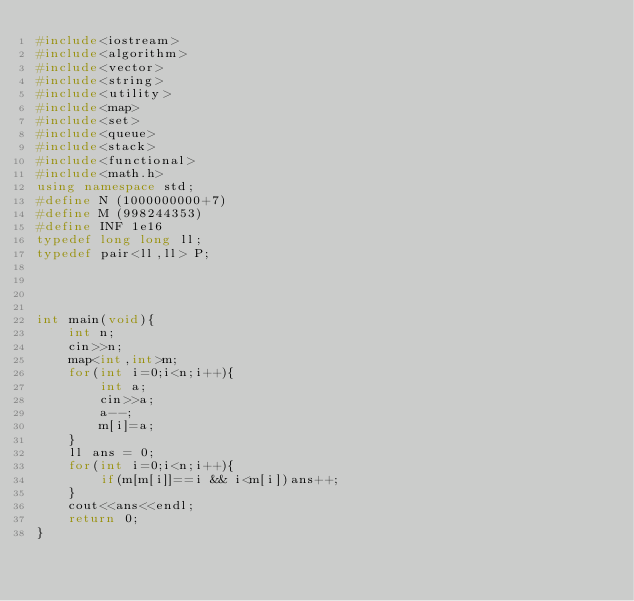Convert code to text. <code><loc_0><loc_0><loc_500><loc_500><_C++_>#include<iostream>
#include<algorithm>
#include<vector>
#include<string>
#include<utility>
#include<map>
#include<set>
#include<queue>
#include<stack>
#include<functional>
#include<math.h>
using namespace std;
#define N (1000000000+7)
#define M (998244353)
#define INF 1e16
typedef long long ll;
typedef pair<ll,ll> P;
 
 

 
int main(void){
    int n;
    cin>>n;
    map<int,int>m;
    for(int i=0;i<n;i++){
        int a;
        cin>>a;
        a--;
        m[i]=a;
    }
    ll ans = 0;
    for(int i=0;i<n;i++){
        if(m[m[i]]==i && i<m[i])ans++;
    }
    cout<<ans<<endl;
    return 0;
}</code> 